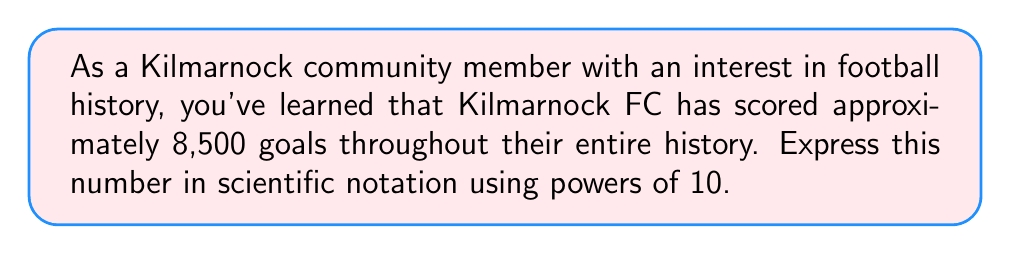Give your solution to this math problem. To express 8,500 in scientific notation using powers of 10, we need to follow these steps:

1) First, we need to identify the first non-zero digit. In this case, it's 8.

2) We then need to move the decimal point to the right of this digit. In our case:

   $8.500 \times 10^n$

3) Now, we count how many places we moved the decimal point. We moved it 3 places to the left.

4) Therefore, our exponent will be 3:

   $8.500 \times 10^3$

5) We can simplify this further by removing the trailing zeros after the decimal point:

   $8.5 \times 10^3$

This is the standard form of scientific notation for 8,500.
Answer: $8.5 \times 10^3$ 